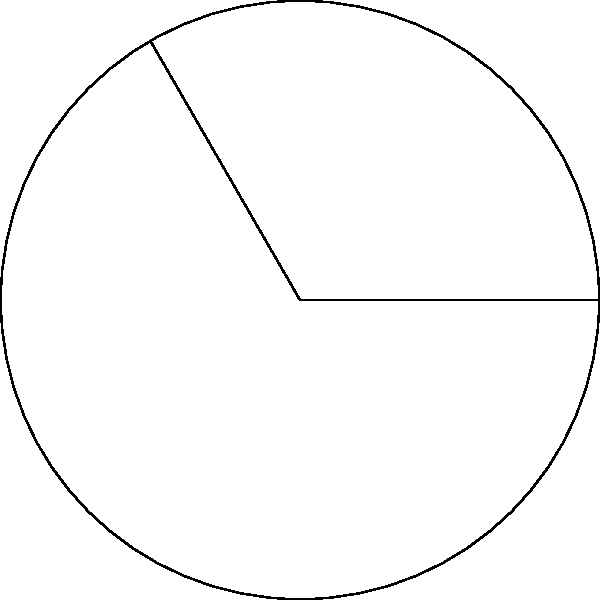A vocal coach wants to represent a singer's vocal range using a circular diagram. The circle has a radius of 3 cm, and the singer's range covers an arc of 120°. Calculate the length of the arc representing the singer's vocal range. To calculate the arc length, we'll follow these steps:

1) The formula for arc length is:
   $$s = \frac{\theta}{360°} \cdot 2\pi r$$
   where $s$ is the arc length, $\theta$ is the central angle in degrees, and $r$ is the radius.

2) We're given:
   $\theta = 120°$
   $r = 3$ cm

3) Let's substitute these values into the formula:
   $$s = \frac{120°}{360°} \cdot 2\pi \cdot 3$$

4) Simplify the fraction:
   $$s = \frac{1}{3} \cdot 2\pi \cdot 3$$

5) Cancel out the 3:
   $$s = 2\pi$$

6) Calculate the final value:
   $$s = 2 \cdot 3.14159... \approx 6.28$$

Therefore, the arc length is approximately 6.28 cm.
Answer: $2\pi$ cm or approximately 6.28 cm 